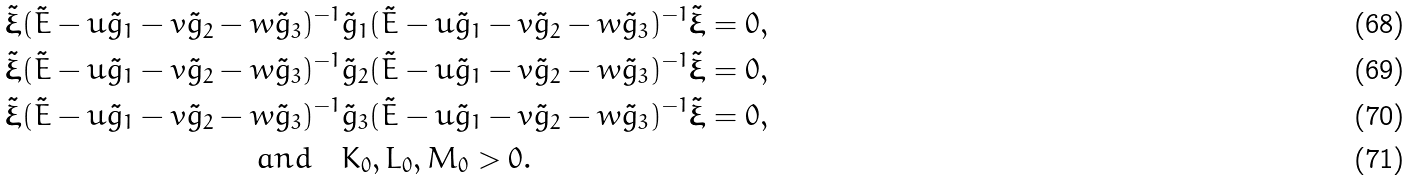<formula> <loc_0><loc_0><loc_500><loc_500>\tilde { \boldsymbol \xi } ( \tilde { E } - u \tilde { g } _ { 1 } - v \tilde { g } _ { 2 } - w \tilde { g } _ { 3 } ) ^ { - 1 } & \tilde { g } _ { 1 } ( \tilde { E } - u \tilde { g } _ { 1 } - v \tilde { g } _ { 2 } - w \tilde { g } _ { 3 } ) ^ { - 1 } \tilde { \boldsymbol \xi } = 0 , \\ \tilde { \boldsymbol \xi } ( \tilde { E } - u \tilde { g } _ { 1 } - v \tilde { g } _ { 2 } - w \tilde { g } _ { 3 } ) ^ { - 1 } & \tilde { g } _ { 2 } ( \tilde { E } - u \tilde { g } _ { 1 } - v \tilde { g } _ { 2 } - w \tilde { g } _ { 3 } ) ^ { - 1 } \tilde { \boldsymbol \xi } = 0 , \\ \tilde { \boldsymbol \xi } ( \tilde { E } - u \tilde { g } _ { 1 } - v \tilde { g } _ { 2 } - w \tilde { g } _ { 3 } ) ^ { - 1 } & \tilde { g } _ { 3 } ( \tilde { E } - u \tilde { g } _ { 1 } - v \tilde { g } _ { 2 } - w \tilde { g } _ { 3 } ) ^ { - 1 } \tilde { \boldsymbol \xi } = 0 , \\ a n d \quad & K _ { 0 } , L _ { 0 } , M _ { 0 } > 0 .</formula> 